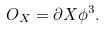<formula> <loc_0><loc_0><loc_500><loc_500>O _ { X } = \partial X \phi ^ { 3 } .</formula> 